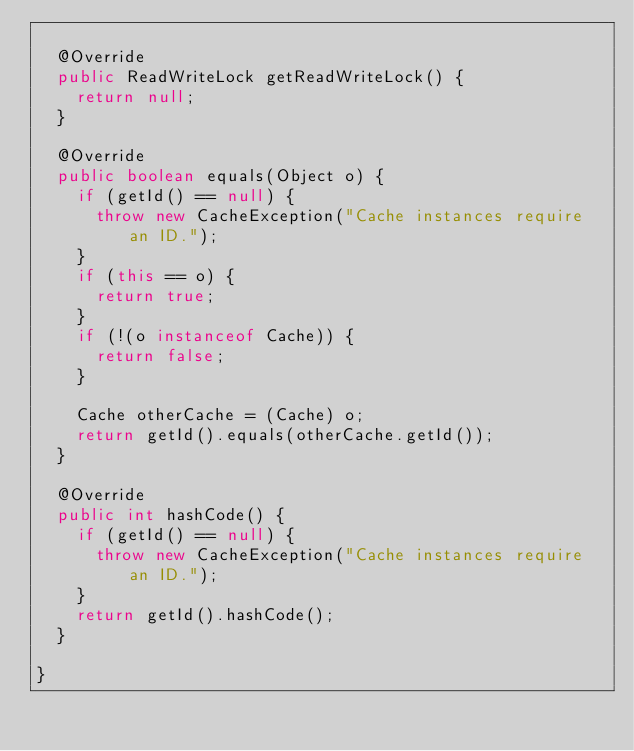<code> <loc_0><loc_0><loc_500><loc_500><_Java_>
  @Override
  public ReadWriteLock getReadWriteLock() {
    return null;
  }

  @Override
  public boolean equals(Object o) {
    if (getId() == null) {
      throw new CacheException("Cache instances require an ID.");
    }
    if (this == o) {
      return true;
    }
    if (!(o instanceof Cache)) {
      return false;
    }

    Cache otherCache = (Cache) o;
    return getId().equals(otherCache.getId());
  }

  @Override
  public int hashCode() {
    if (getId() == null) {
      throw new CacheException("Cache instances require an ID.");
    }
    return getId().hashCode();
  }

}
</code> 